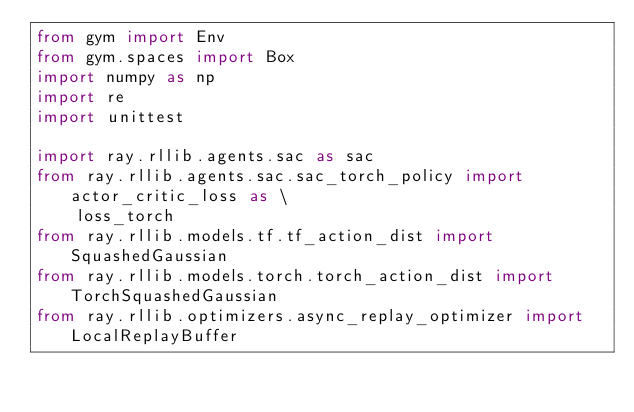Convert code to text. <code><loc_0><loc_0><loc_500><loc_500><_Python_>from gym import Env
from gym.spaces import Box
import numpy as np
import re
import unittest

import ray.rllib.agents.sac as sac
from ray.rllib.agents.sac.sac_torch_policy import actor_critic_loss as \
    loss_torch
from ray.rllib.models.tf.tf_action_dist import SquashedGaussian
from ray.rllib.models.torch.torch_action_dist import TorchSquashedGaussian
from ray.rllib.optimizers.async_replay_optimizer import LocalReplayBuffer</code> 